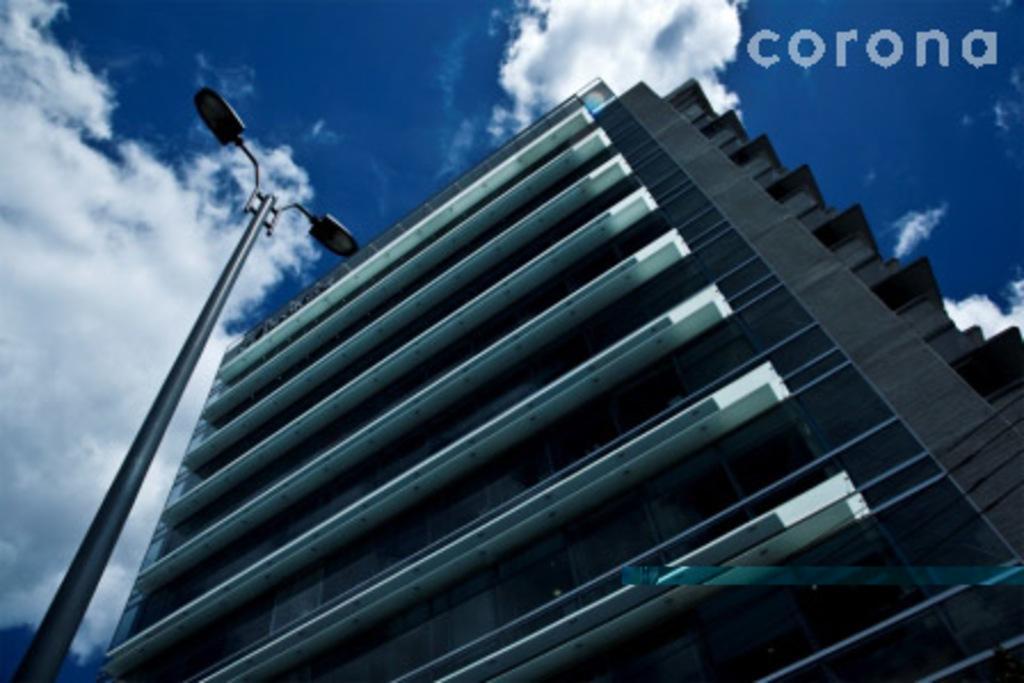Can you describe this image briefly? This is an edited picture. In this image there is a building. On the left side of the image there is a street light. At the top there is sky and there are clouds. At the top there right there is text. 